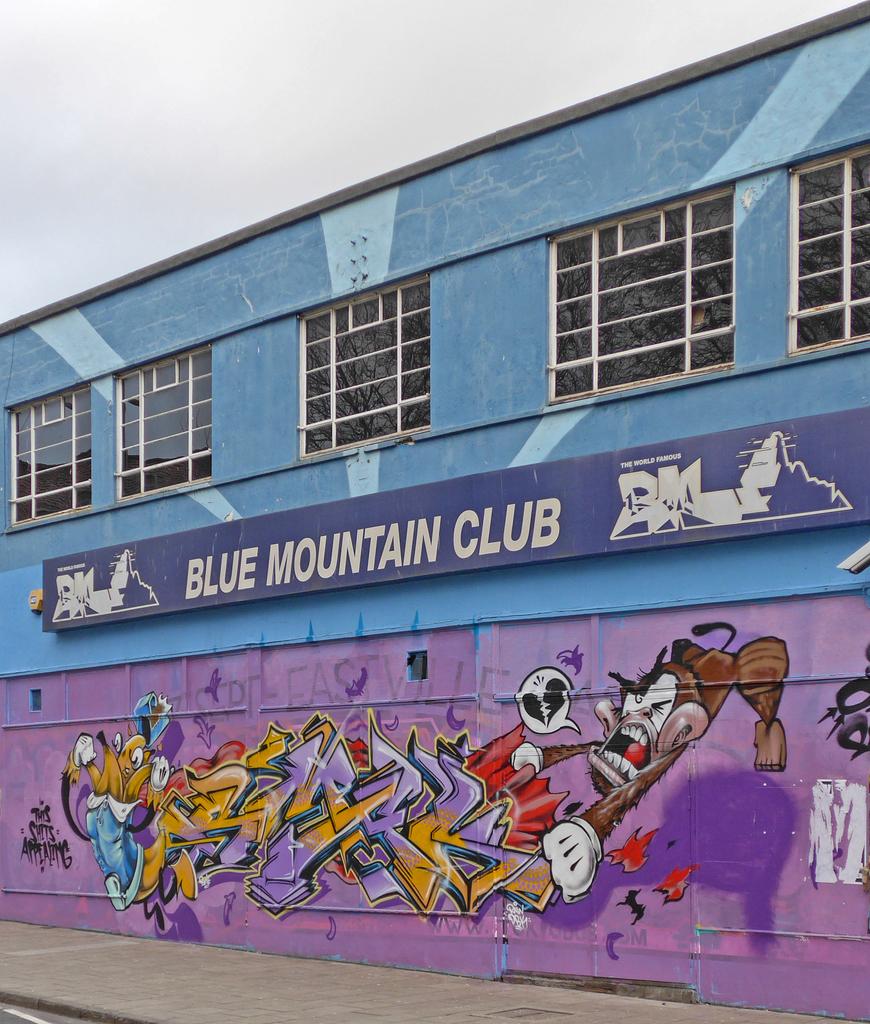What is the name of the club?
Offer a terse response. Blue mountain club. What is written above the blue mountain logo?
Offer a terse response. The world famous. 